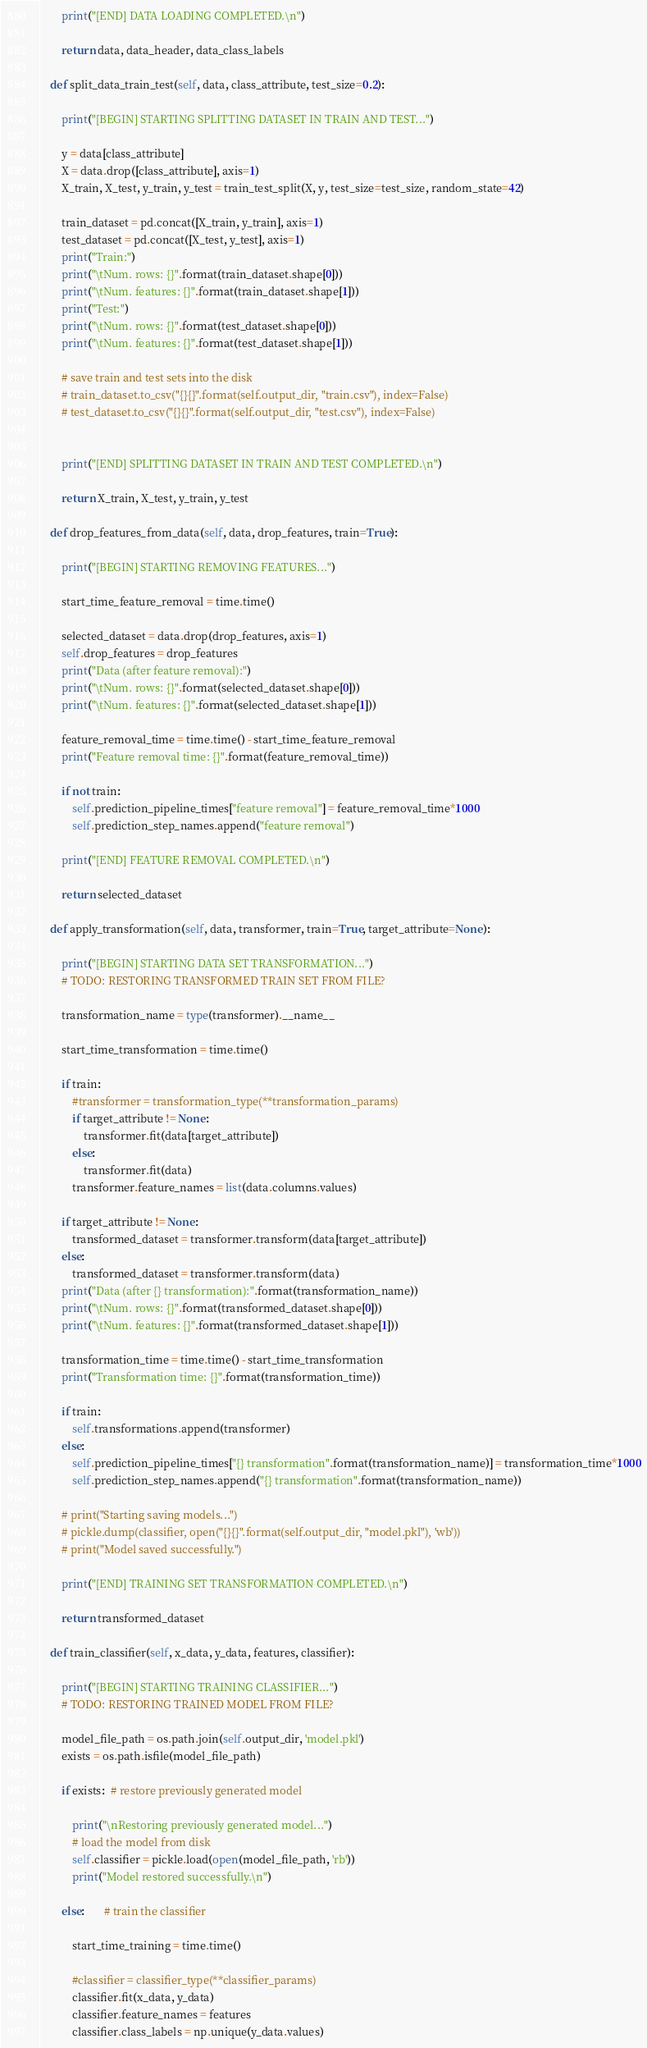<code> <loc_0><loc_0><loc_500><loc_500><_Python_>
        print("[END] DATA LOADING COMPLETED.\n")

        return data, data_header, data_class_labels

    def split_data_train_test(self, data, class_attribute, test_size=0.2):

        print("[BEGIN] STARTING SPLITTING DATASET IN TRAIN AND TEST...")

        y = data[class_attribute]
        X = data.drop([class_attribute], axis=1)
        X_train, X_test, y_train, y_test = train_test_split(X, y, test_size=test_size, random_state=42)

        train_dataset = pd.concat([X_train, y_train], axis=1)
        test_dataset = pd.concat([X_test, y_test], axis=1)
        print("Train:")
        print("\tNum. rows: {}".format(train_dataset.shape[0]))
        print("\tNum. features: {}".format(train_dataset.shape[1]))
        print("Test:")
        print("\tNum. rows: {}".format(test_dataset.shape[0]))
        print("\tNum. features: {}".format(test_dataset.shape[1]))

        # save train and test sets into the disk
        # train_dataset.to_csv("{}{}".format(self.output_dir, "train.csv"), index=False)
        # test_dataset.to_csv("{}{}".format(self.output_dir, "test.csv"), index=False)


        print("[END] SPLITTING DATASET IN TRAIN AND TEST COMPLETED.\n")

        return X_train, X_test, y_train, y_test

    def drop_features_from_data(self, data, drop_features, train=True):

        print("[BEGIN] STARTING REMOVING FEATURES...")

        start_time_feature_removal = time.time()

        selected_dataset = data.drop(drop_features, axis=1)
        self.drop_features = drop_features
        print("Data (after feature removal):")
        print("\tNum. rows: {}".format(selected_dataset.shape[0]))
        print("\tNum. features: {}".format(selected_dataset.shape[1]))

        feature_removal_time = time.time() - start_time_feature_removal
        print("Feature removal time: {}".format(feature_removal_time))

        if not train:
            self.prediction_pipeline_times["feature removal"] = feature_removal_time*1000
            self.prediction_step_names.append("feature removal")

        print("[END] FEATURE REMOVAL COMPLETED.\n")

        return selected_dataset

    def apply_transformation(self, data, transformer, train=True, target_attribute=None):

        print("[BEGIN] STARTING DATA SET TRANSFORMATION...")
        # TODO: RESTORING TRANSFORMED TRAIN SET FROM FILE?

        transformation_name = type(transformer).__name__

        start_time_transformation = time.time()

        if train:
            #transformer = transformation_type(**transformation_params)
            if target_attribute != None:
                transformer.fit(data[target_attribute])
            else:
                transformer.fit(data)
            transformer.feature_names = list(data.columns.values)

        if target_attribute != None:
            transformed_dataset = transformer.transform(data[target_attribute])
        else:
            transformed_dataset = transformer.transform(data)
        print("Data (after {} transformation):".format(transformation_name))
        print("\tNum. rows: {}".format(transformed_dataset.shape[0]))
        print("\tNum. features: {}".format(transformed_dataset.shape[1]))

        transformation_time = time.time() - start_time_transformation
        print("Transformation time: {}".format(transformation_time))

        if train:
            self.transformations.append(transformer)
        else:
            self.prediction_pipeline_times["{} transformation".format(transformation_name)] = transformation_time*1000
            self.prediction_step_names.append("{} transformation".format(transformation_name))

        # print("Starting saving models...")
        # pickle.dump(classifier, open("{}{}".format(self.output_dir, "model.pkl"), 'wb'))
        # print("Model saved successfully.")

        print("[END] TRAINING SET TRANSFORMATION COMPLETED.\n")

        return transformed_dataset

    def train_classifier(self, x_data, y_data, features, classifier):

        print("[BEGIN] STARTING TRAINING CLASSIFIER...")
        # TODO: RESTORING TRAINED MODEL FROM FILE?

        model_file_path = os.path.join(self.output_dir, 'model.pkl')
        exists = os.path.isfile(model_file_path)

        if exists:  # restore previously generated model

            print("\nRestoring previously generated model...")
            # load the model from disk
            self.classifier = pickle.load(open(model_file_path, 'rb'))
            print("Model restored successfully.\n")

        else:       # train the classifier

            start_time_training = time.time()

            #classifier = classifier_type(**classifier_params)
            classifier.fit(x_data, y_data)
            classifier.feature_names = features
            classifier.class_labels = np.unique(y_data.values)</code> 